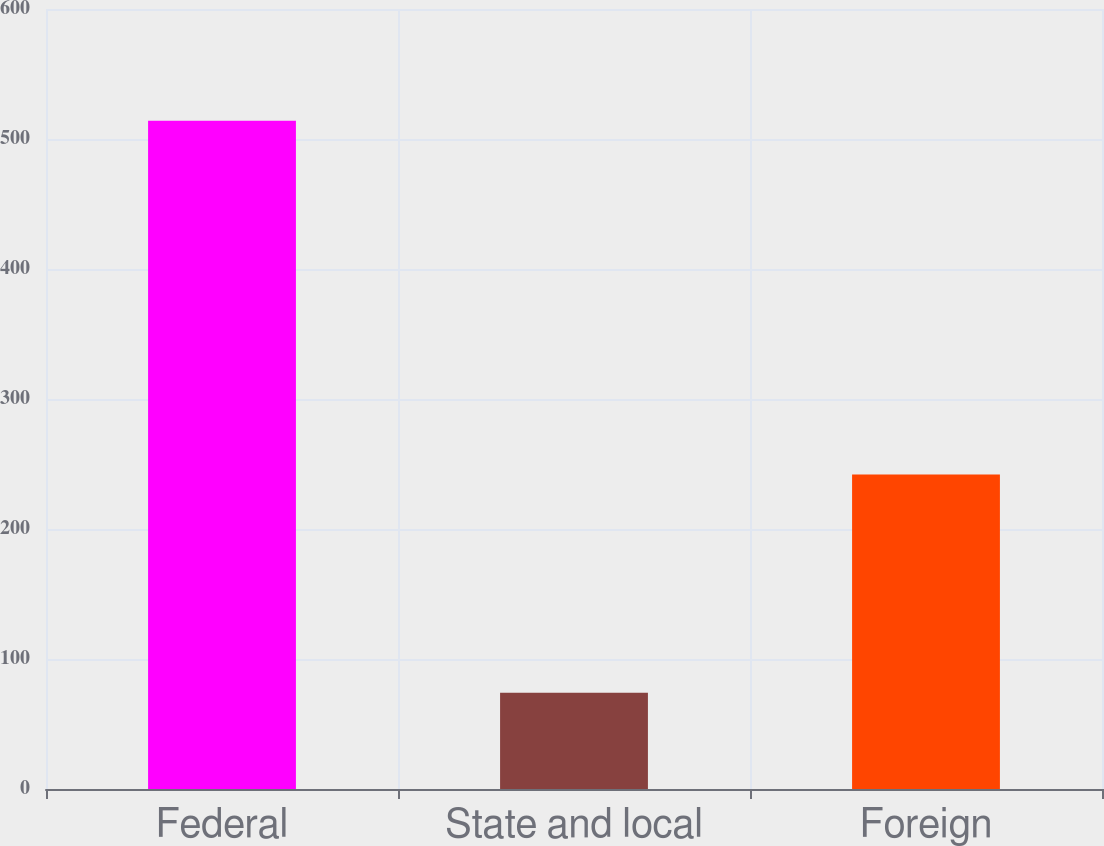<chart> <loc_0><loc_0><loc_500><loc_500><bar_chart><fcel>Federal<fcel>State and local<fcel>Foreign<nl><fcel>514<fcel>74<fcel>242<nl></chart> 